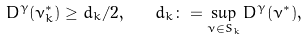<formula> <loc_0><loc_0><loc_500><loc_500>D ^ { \gamma } ( \nu ^ { * } _ { k } ) \geq d _ { k } / 2 , \quad d _ { k } \colon = \sup _ { \nu \in S _ { k } } D ^ { \gamma } ( \nu ^ { * } ) ,</formula> 